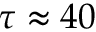<formula> <loc_0><loc_0><loc_500><loc_500>\tau \approx 4 0</formula> 